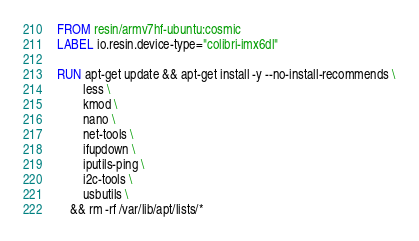Convert code to text. <code><loc_0><loc_0><loc_500><loc_500><_Dockerfile_>FROM resin/armv7hf-ubuntu:cosmic
LABEL io.resin.device-type="colibri-imx6dl"

RUN apt-get update && apt-get install -y --no-install-recommends \
		less \
		kmod \
		nano \
		net-tools \
		ifupdown \
		iputils-ping \
		i2c-tools \
		usbutils \
	&& rm -rf /var/lib/apt/lists/*</code> 